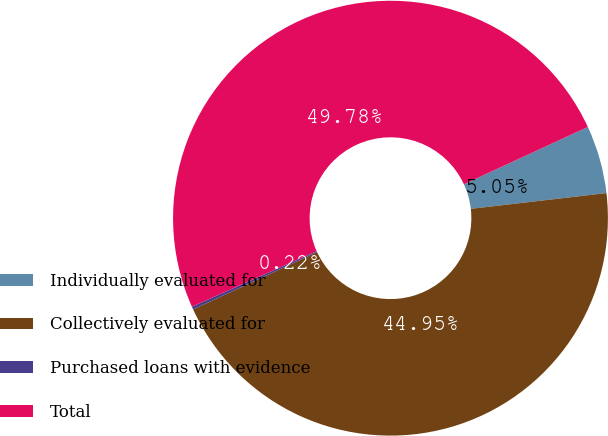Convert chart to OTSL. <chart><loc_0><loc_0><loc_500><loc_500><pie_chart><fcel>Individually evaluated for<fcel>Collectively evaluated for<fcel>Purchased loans with evidence<fcel>Total<nl><fcel>5.05%<fcel>44.95%<fcel>0.22%<fcel>49.78%<nl></chart> 